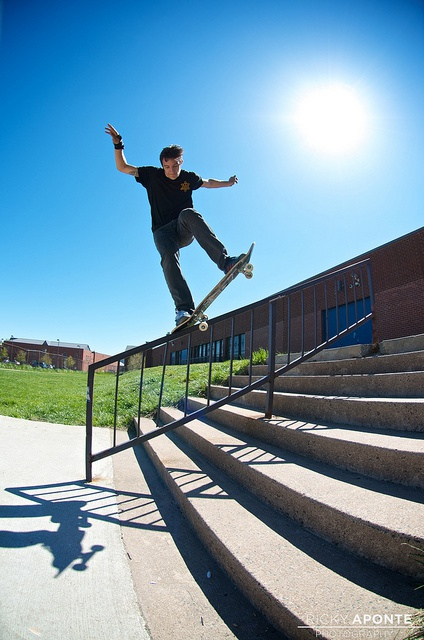Describe the objects in this image and their specific colors. I can see people in darkblue, black, gray, lightblue, and brown tones and skateboard in darkblue, gray, black, and darkgray tones in this image. 